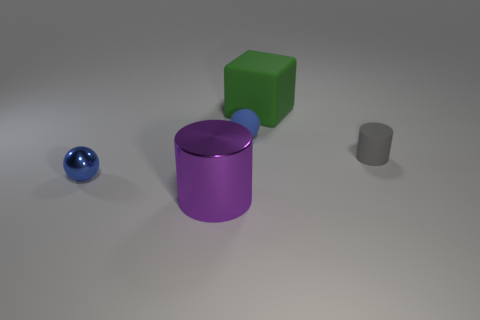What materials do the objects seem to be made of? The objects appear to be made of a matte material that could be rubber or plastic based on the soft reflections and diffused light on their surfaces. 